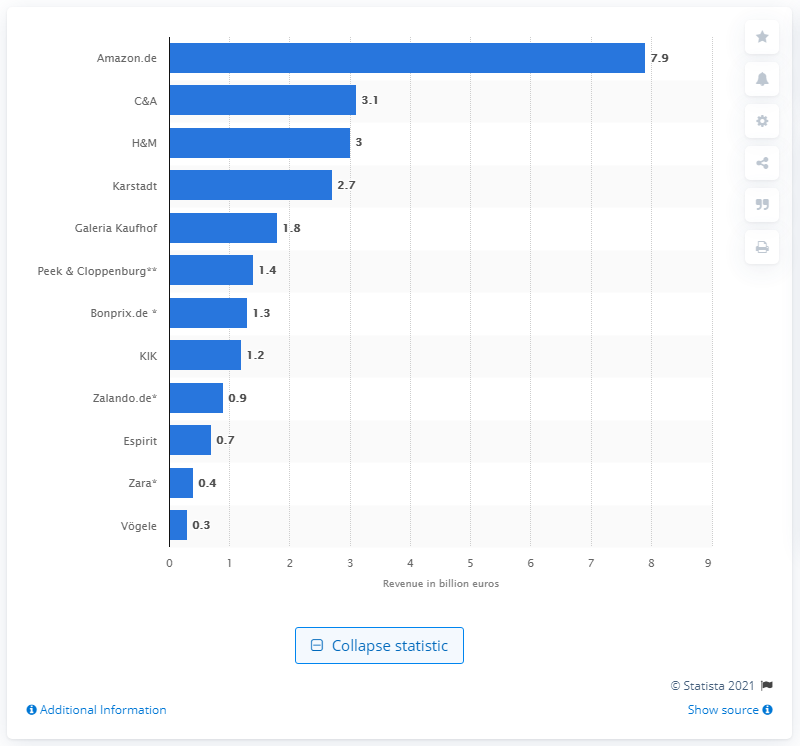Draw attention to some important aspects in this diagram. H&M's revenue in 2013 was approximately 3. In 2013, Amazon.de was the clothing retailer that generated the highest revenue in Germany. 